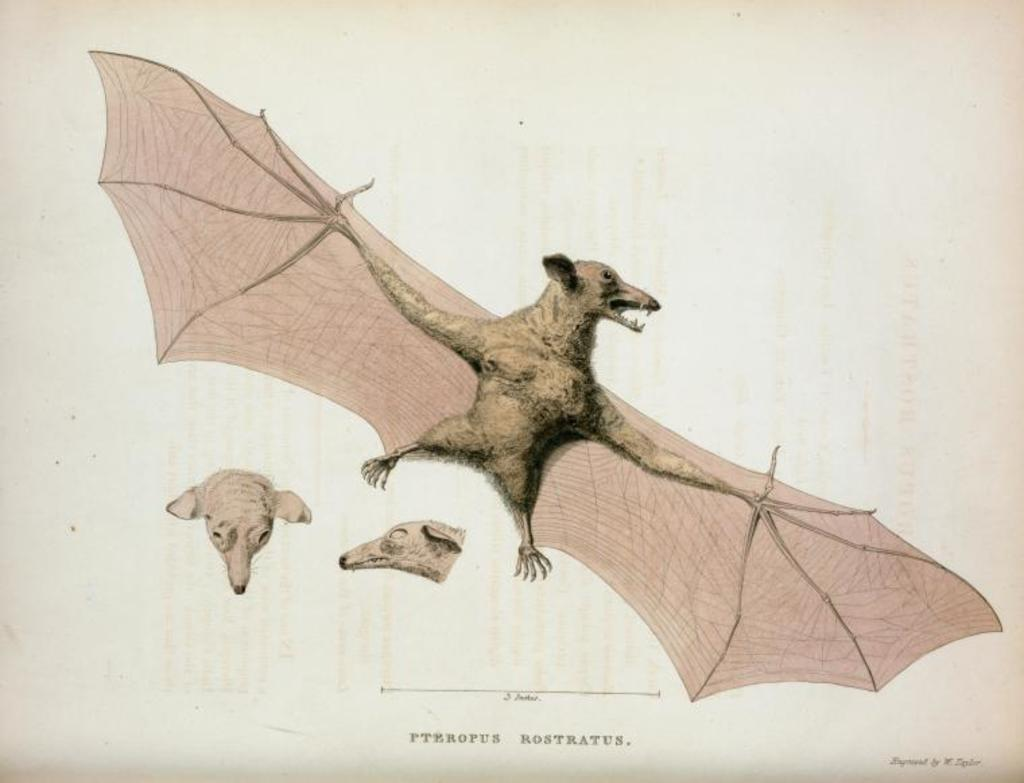What is depicted in the painting in the image? There is a painting of a bat in the image. What else can be seen in the image besides the painting? There is text in the image. How many ladybugs are crawling on the shoes in the image? There are no shoes or ladybugs present in the image. 